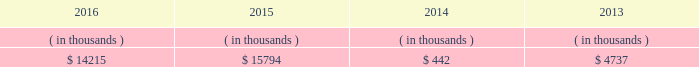Entergy new orleans , inc .
And subsidiaries management 2019s financial discussion and analysis entergy new orleans 2019s receivables from the money pool were as follows as of december 31 for each of the following years. .
See note 4 to the financial statements for a description of the money pool .
Entergy new orleans has a credit facility in the amount of $ 25 million scheduled to expire in november 2018 .
The credit facility allows entergy new orleans to issue letters of credit against $ 10 million of the borrowing capacity of the facility .
As of december 31 , 2016 , there were no cash borrowings and a $ 0.8 million letter of credit was outstanding under the facility .
In addition , entergy new orleans is a party to an uncommitted letter of credit facility as a means to post collateral to support its obligations under miso .
As of december 31 , 2016 , a $ 6.2 million letter of credit was outstanding under entergy new orleans 2019s letter of credit facility .
See note 4 to the financial statements for additional discussion of the credit facilities .
Entergy new orleans obtained authorization from the ferc through october 2017 for short-term borrowings not to exceed an aggregate amount of $ 100 million at any time outstanding .
See note 4 to the financial statements for further discussion of entergy new orleans 2019s short-term borrowing limits .
The long-term securities issuances of entergy new orleans are limited to amounts authorized by the city council , and the current authorization extends through june 2018 .
State and local rate regulation the rates that entergy new orleans charges for electricity and natural gas significantly influence its financial position , results of operations , and liquidity .
Entergy new orleans is regulated and the rates charged to its customers are determined in regulatory proceedings .
A governmental agency , the city council , is primarily responsible for approval of the rates charged to customers .
Retail rates see 201calgiers asset transfer 201d below for discussion of the transfer from entergy louisiana to entergy new orleans of certain assets that serve algiers customers .
In march 2013 , entergy louisiana filed a rate case for the algiers area , which is in new orleans and is regulated by the city council .
Entergy louisiana requested a rate increase of $ 13 million over three years , including a 10.4% ( 10.4 % ) return on common equity and a formula rate plan mechanism identical to its lpsc request .
In january 2014 the city council advisors filed direct testimony recommending a rate increase of $ 5.56 million over three years , including an 8.13% ( 8.13 % ) return on common equity .
In june 2014 the city council unanimously approved a settlement that includes the following : 2022 a $ 9.3 million base rate revenue increase to be phased in on a levelized basis over four years ; 2022 recovery of an additional $ 853 thousand annually through a miso recovery rider ; and 2022 the adoption of a four-year formula rate plan requiring the filing of annual evaluation reports in may of each year , commencing may 2015 , with resulting rates being implemented in october of each year .
The formula rate plan includes a midpoint target authorized return on common equity of 9.95% ( 9.95 % ) with a +/- 40 basis point bandwidth .
The rate increase was effective with bills rendered on and after the first billing cycle of july 2014 .
Additional compliance filings were made with the city council in october 2014 for approval of the form of certain rate riders , including among others , a ninemile 6 non-fuel cost recovery interim rider , allowing for contemporaneous recovery of capacity .
What is the net change in entergy new orleans 2019s receivables from the money pool from 2015 to 2016? 
Computations: (14215 - 15794)
Answer: -1579.0. 